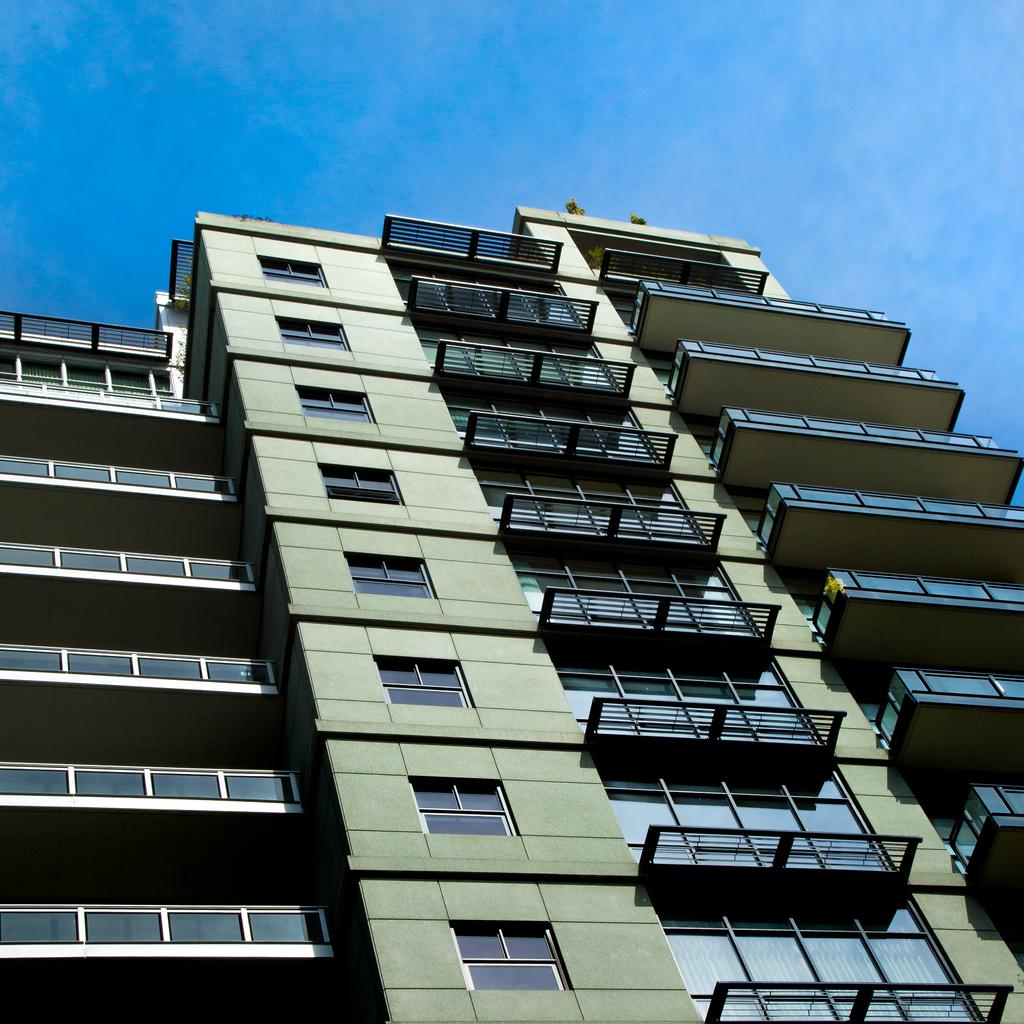What type of structure is present in the image? There is a building in the image. What can be seen at the top of the image? The sky is visible at the top of the image. Where are the dinosaurs playing basketball in the image? There are no dinosaurs or basketball present in the image; it only features a building and the sky. 